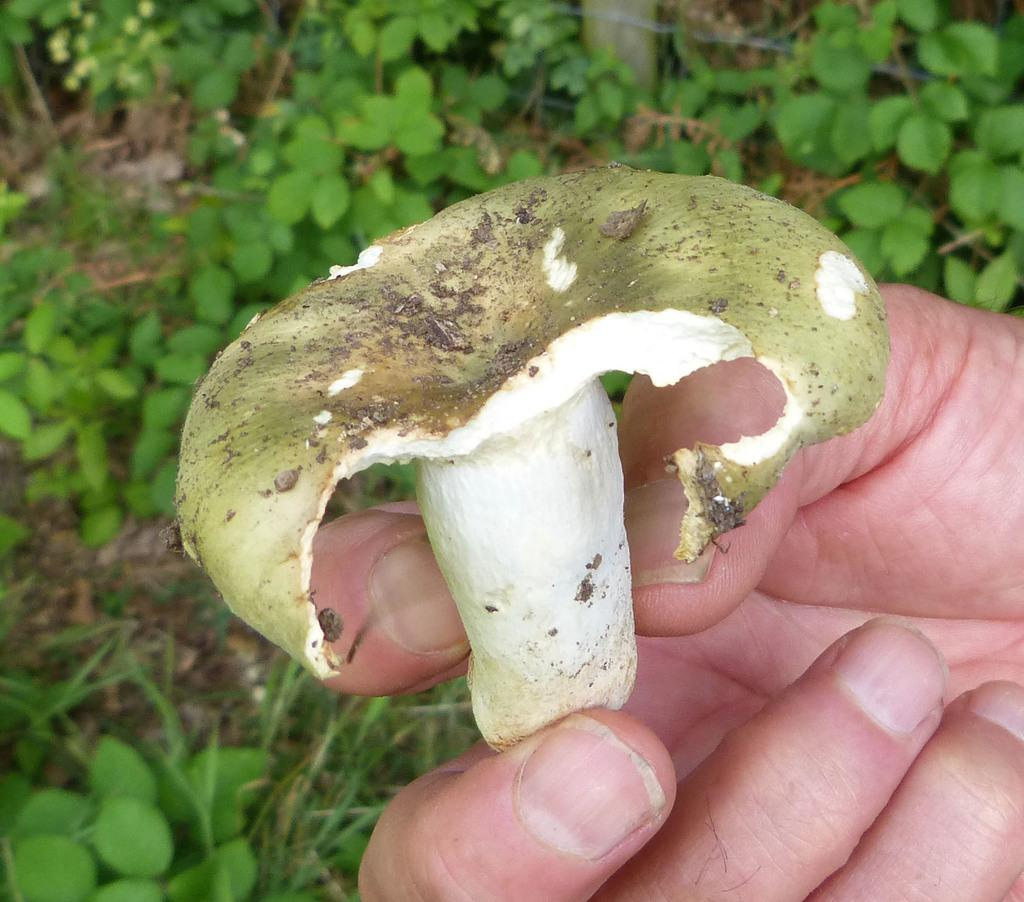What type of living organisms can be seen in the image? Plants can be seen in the image. What object is being held by a person's hand in the image? A person's hand is holding a mushroom in the image. What type of hydrant can be seen in the image? There is no hydrant present in the image. Where is the meeting taking place in the image? There is no meeting depicted in the image. 